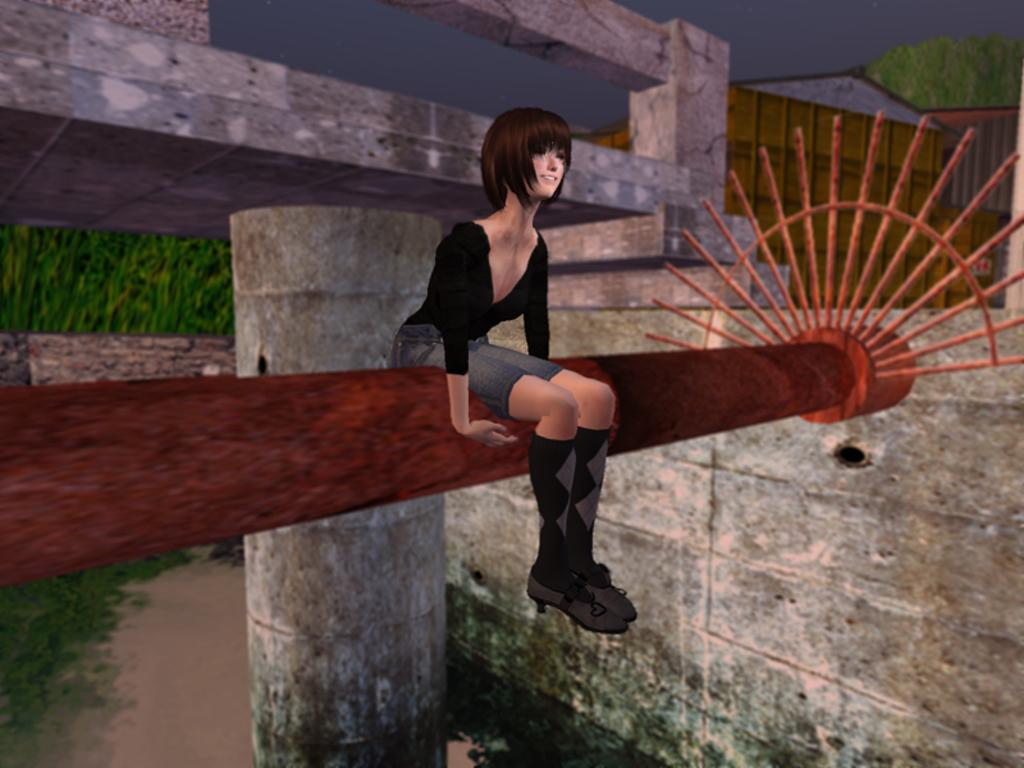What type of image is being described? The image is an animated image. Who or what is the main subject in the image? There is a girl in the image. What is the girl doing in the image? The girl is sitting in the image. On what is the girl sitting? The girl is sitting on a wooden object. What type of pear is being harvested on the plantation in the image? There is no plantation or pear present in the image; it features an animated girl sitting on a wooden object. How many cats are visible in the image? There are no cats present in the image. 